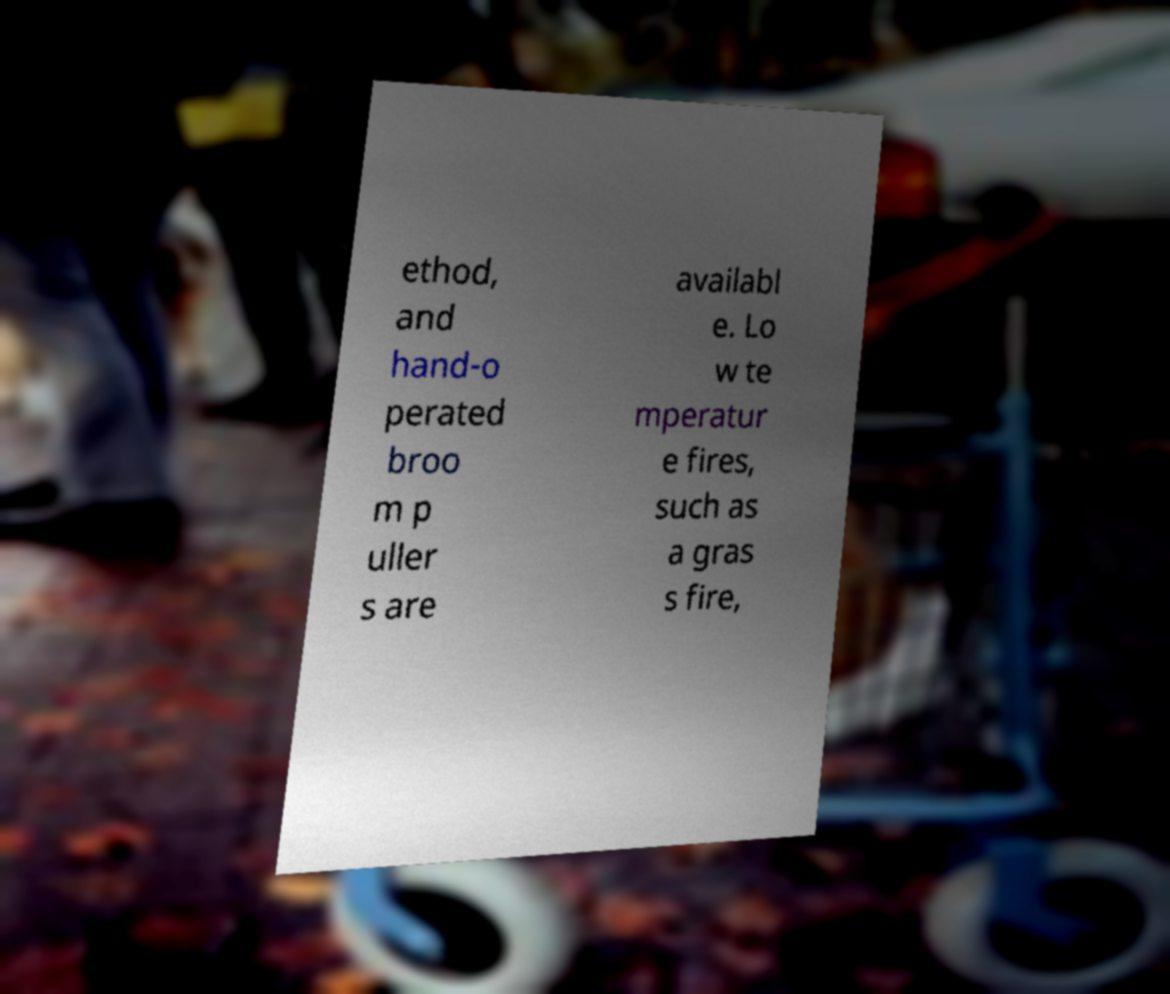Can you read and provide the text displayed in the image?This photo seems to have some interesting text. Can you extract and type it out for me? ethod, and hand-o perated broo m p uller s are availabl e. Lo w te mperatur e fires, such as a gras s fire, 